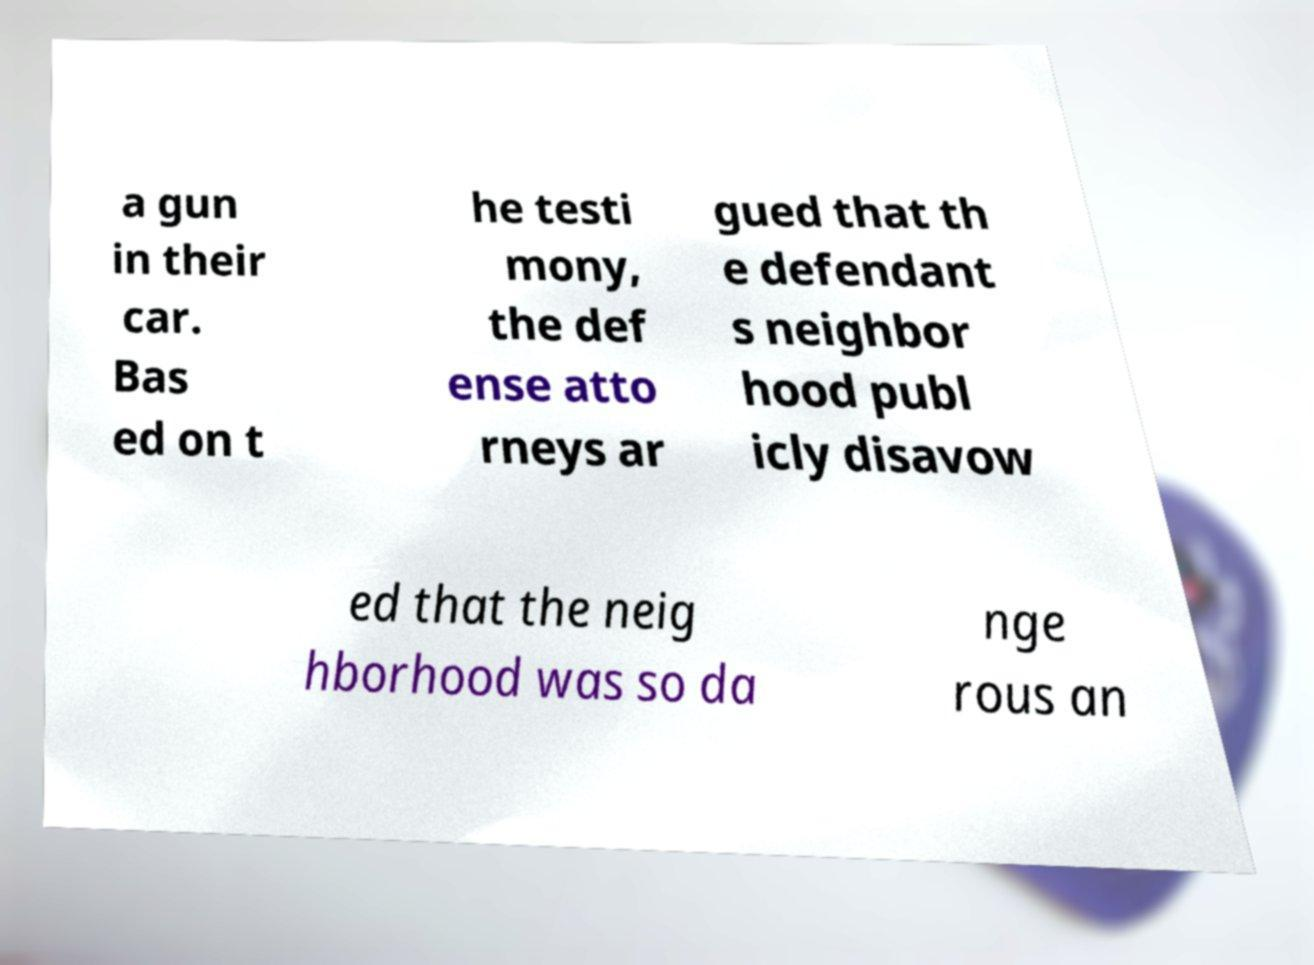For documentation purposes, I need the text within this image transcribed. Could you provide that? a gun in their car. Bas ed on t he testi mony, the def ense atto rneys ar gued that th e defendant s neighbor hood publ icly disavow ed that the neig hborhood was so da nge rous an 